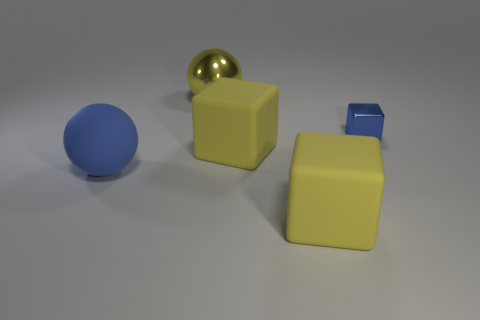Add 3 yellow cubes. How many objects exist? 8 Subtract all cubes. How many objects are left? 2 Add 2 small blue metallic cubes. How many small blue metallic cubes exist? 3 Subtract 1 blue blocks. How many objects are left? 4 Subtract all small brown rubber blocks. Subtract all big yellow shiny things. How many objects are left? 4 Add 1 tiny blue blocks. How many tiny blue blocks are left? 2 